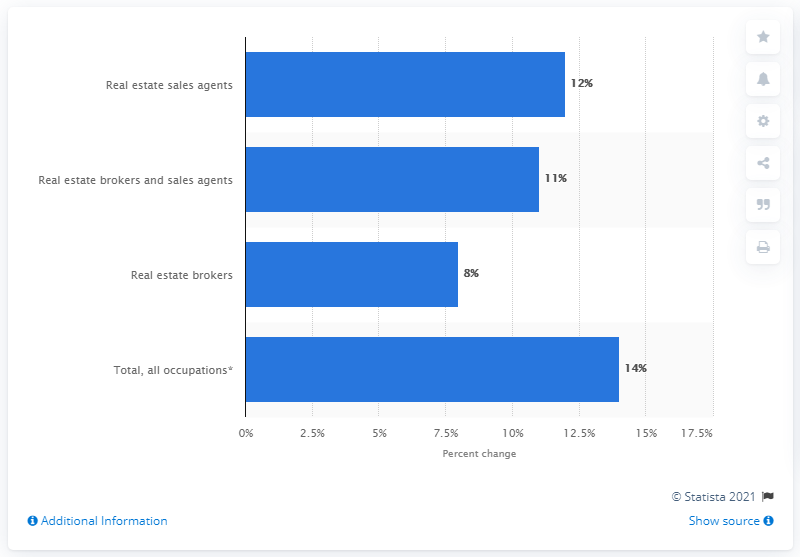List a handful of essential elements in this visual. The projected growth of employment for real estate sales agents between 2010 and 2020 is expected to be approximately 9.15%. 